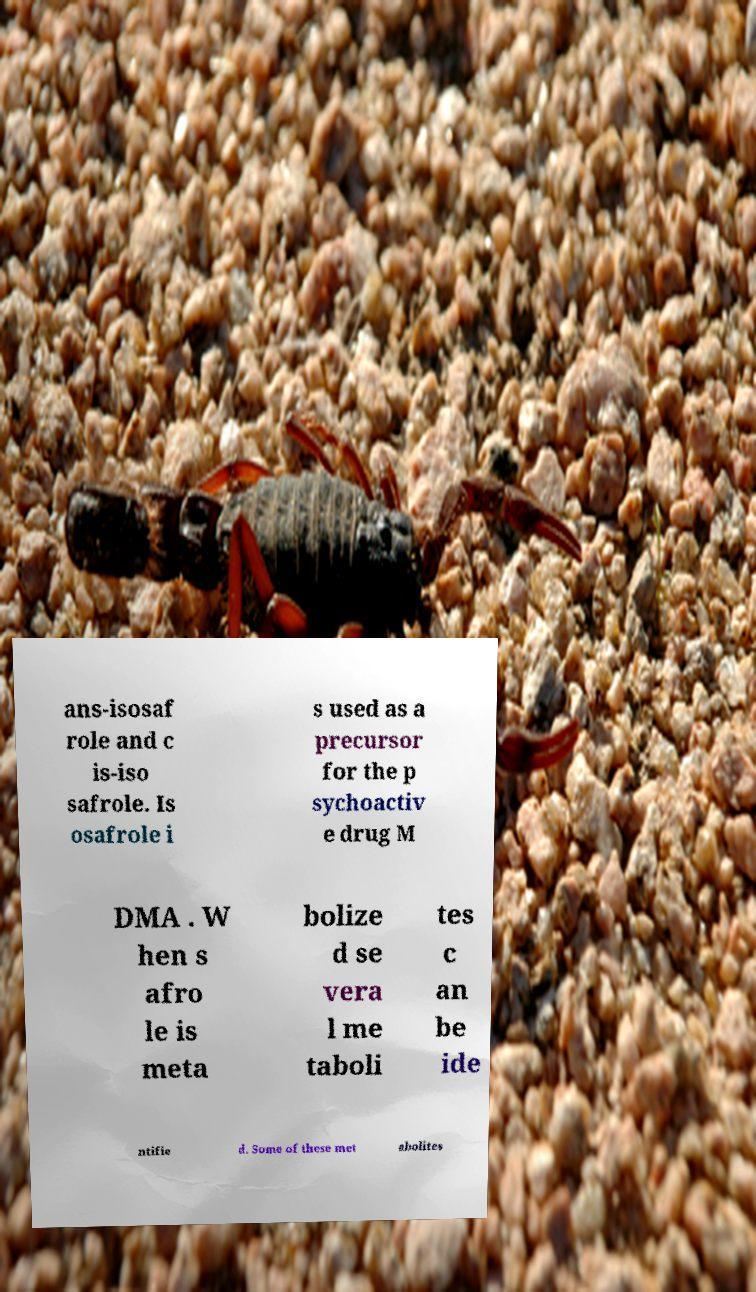Can you read and provide the text displayed in the image?This photo seems to have some interesting text. Can you extract and type it out for me? ans-isosaf role and c is-iso safrole. Is osafrole i s used as a precursor for the p sychoactiv e drug M DMA . W hen s afro le is meta bolize d se vera l me taboli tes c an be ide ntifie d. Some of these met abolites 